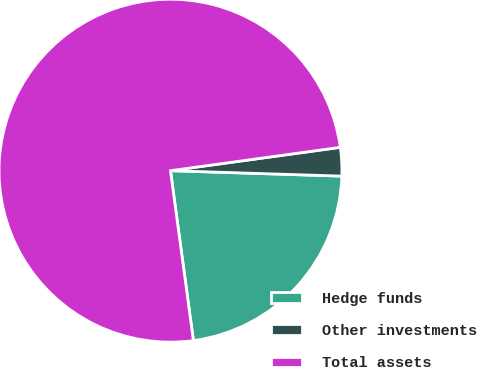Convert chart. <chart><loc_0><loc_0><loc_500><loc_500><pie_chart><fcel>Hedge funds<fcel>Other investments<fcel>Total assets<nl><fcel>22.36%<fcel>2.68%<fcel>74.96%<nl></chart> 